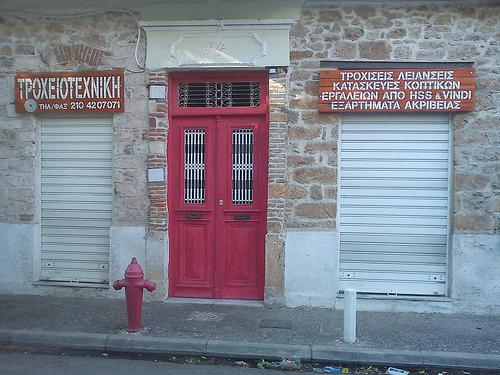Question: what is the store's phone number?
Choices:
A. 2104207071.
B. 7405224851.
C. 8779285531.
D. 6142916652.
Answer with the letter. Answer: A Question: where is the store's address?
Choices:
A. In phonebook.
B. On door.
C. Above the door.
D. On curb.
Answer with the letter. Answer: C Question: why are the shutters on the window down?
Choices:
A. The store is closed.
B. Storm coming.
C. Blocking sun.
D. Broken.
Answer with the letter. Answer: A Question: where is the fire hydrant?
Choices:
A. On the street corner.
B. Beside sidewalk.
C. In front of house.
D. In front of the door.
Answer with the letter. Answer: D Question: what language are the signs in?
Choices:
A. Greek.
B. Chinese.
C. Russian.
D. English.
Answer with the letter. Answer: A Question: how many windows are on the door?
Choices:
A. 2.
B. 0.
C. 1.
D. 3.
Answer with the letter. Answer: D Question: when was this picture taken?
Choices:
A. During wedding.
B. During the day.
C. At sunset.
D. At dinner.
Answer with the letter. Answer: B 